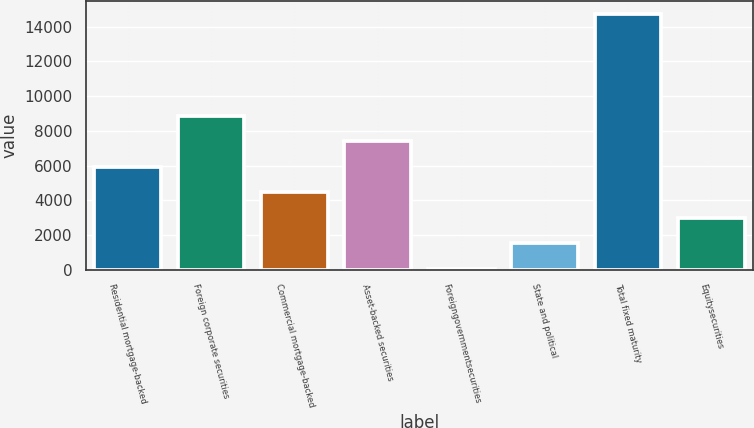Convert chart. <chart><loc_0><loc_0><loc_500><loc_500><bar_chart><fcel>Residential mortgage-backed<fcel>Foreign corporate securities<fcel>Commercial mortgage-backed<fcel>Asset-backed securities<fcel>Foreigngovernmentsecurities<fcel>State and political<fcel>Total fixed maturity<fcel>Equitysecurities<nl><fcel>5940.2<fcel>8879.8<fcel>4470.4<fcel>7410<fcel>61<fcel>1530.8<fcel>14759<fcel>3000.6<nl></chart> 